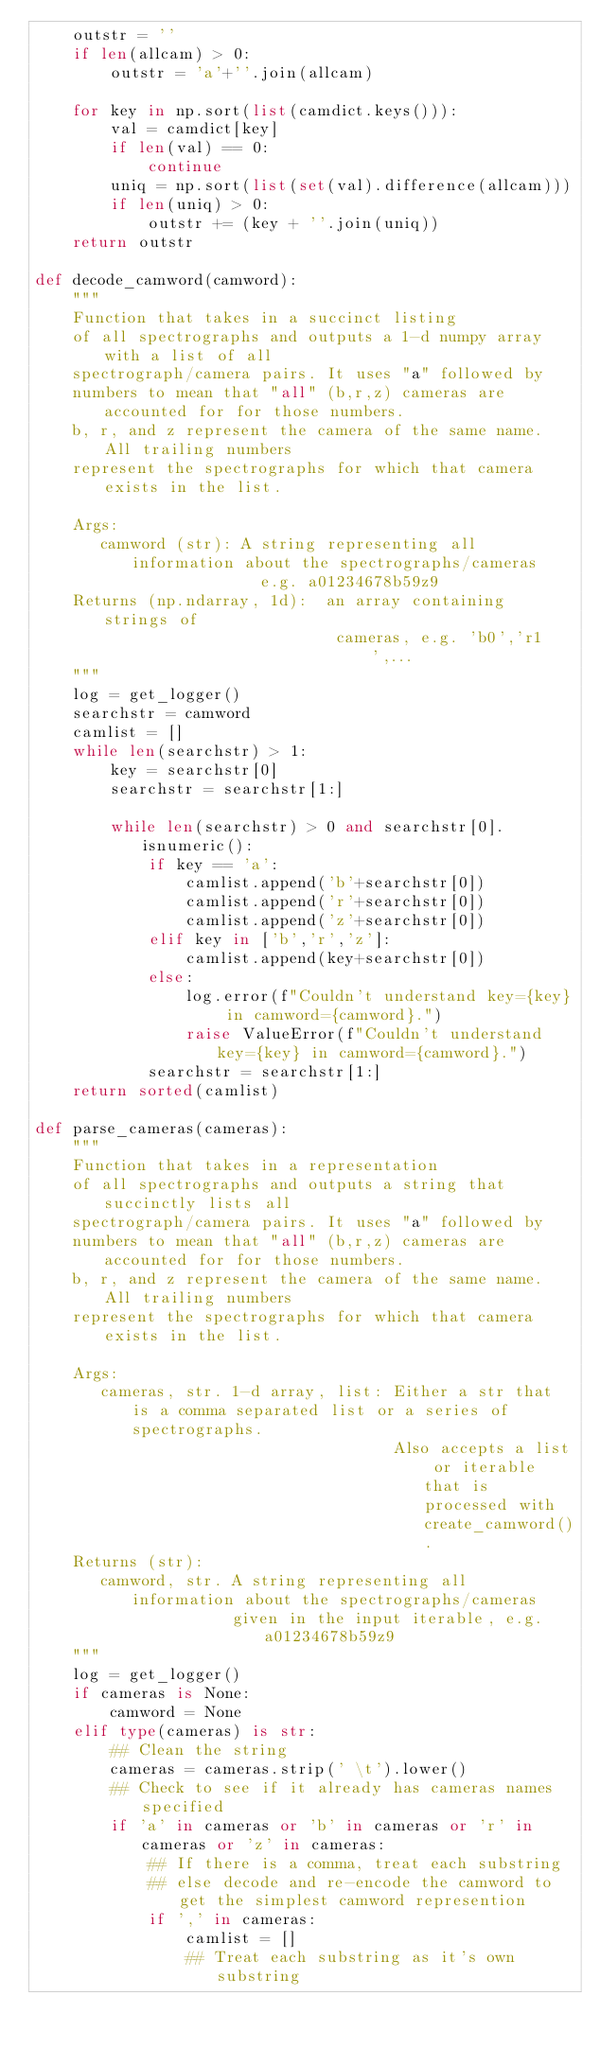Convert code to text. <code><loc_0><loc_0><loc_500><loc_500><_Python_>    outstr = ''
    if len(allcam) > 0:
        outstr = 'a'+''.join(allcam)

    for key in np.sort(list(camdict.keys())):
        val = camdict[key]
        if len(val) == 0:
            continue
        uniq = np.sort(list(set(val).difference(allcam)))
        if len(uniq) > 0:
            outstr += (key + ''.join(uniq))
    return outstr

def decode_camword(camword):
    """
    Function that takes in a succinct listing
    of all spectrographs and outputs a 1-d numpy array with a list of all
    spectrograph/camera pairs. It uses "a" followed by                                                      
    numbers to mean that "all" (b,r,z) cameras are accounted for for those numbers.                                             
    b, r, and z represent the camera of the same name. All trailing numbers                                                     
    represent the spectrographs for which that camera exists in the list.                                                       
                                                                                                                                
    Args:                      
       camword (str): A string representing all information about the spectrographs/cameras                                    
                        e.g. a01234678b59z9                                                                                                  
    Returns (np.ndarray, 1d):  an array containing strings of                                                              
                                cameras, e.g. 'b0','r1',...                                                                
    """
    log = get_logger()
    searchstr = camword
    camlist = []
    while len(searchstr) > 1:
        key = searchstr[0]
        searchstr = searchstr[1:]

        while len(searchstr) > 0 and searchstr[0].isnumeric():
            if key == 'a':
                camlist.append('b'+searchstr[0])
                camlist.append('r'+searchstr[0])
                camlist.append('z'+searchstr[0])
            elif key in ['b','r','z']:
                camlist.append(key+searchstr[0])
            else:
                log.error(f"Couldn't understand key={key} in camword={camword}.")
                raise ValueError(f"Couldn't understand key={key} in camword={camword}.")
            searchstr = searchstr[1:]
    return sorted(camlist)

def parse_cameras(cameras):
    """
    Function that takes in a representation
    of all spectrographs and outputs a string that succinctly lists all
    spectrograph/camera pairs. It uses "a" followed by
    numbers to mean that "all" (b,r,z) cameras are accounted for for those numbers.
    b, r, and z represent the camera of the same name. All trailing numbers
    represent the spectrographs for which that camera exists in the list.

    Args:
       cameras, str. 1-d array, list: Either a str that is a comma separated list or a series of spectrographs.
                                      Also accepts a list or iterable that is processed with create_camword().
    Returns (str):
       camword, str. A string representing all information about the spectrographs/cameras
                     given in the input iterable, e.g. a01234678b59z9
    """
    log = get_logger()
    if cameras is None:
        camword = None
    elif type(cameras) is str:
        ## Clean the string
        cameras = cameras.strip(' \t').lower()
        ## Check to see if it already has cameras names specified
        if 'a' in cameras or 'b' in cameras or 'r' in cameras or 'z' in cameras:
            ## If there is a comma, treat each substring
            ## else decode and re-encode the camword to get the simplest camword represention
            if ',' in cameras:
                camlist = []
                ## Treat each substring as it's own substring</code> 